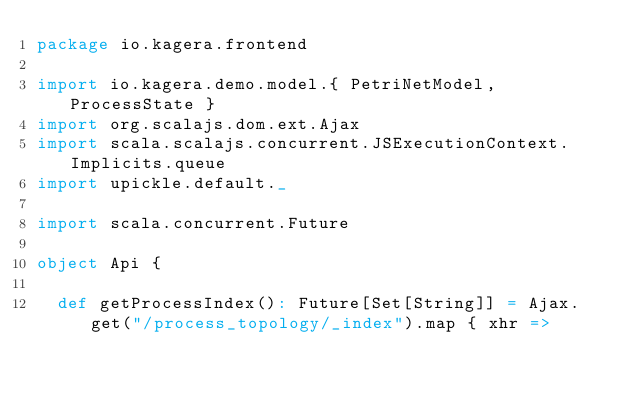<code> <loc_0><loc_0><loc_500><loc_500><_Scala_>package io.kagera.frontend

import io.kagera.demo.model.{ PetriNetModel, ProcessState }
import org.scalajs.dom.ext.Ajax
import scala.scalajs.concurrent.JSExecutionContext.Implicits.queue
import upickle.default._

import scala.concurrent.Future

object Api {

  def getProcessIndex(): Future[Set[String]] = Ajax.get("/process_topology/_index").map { xhr =></code> 